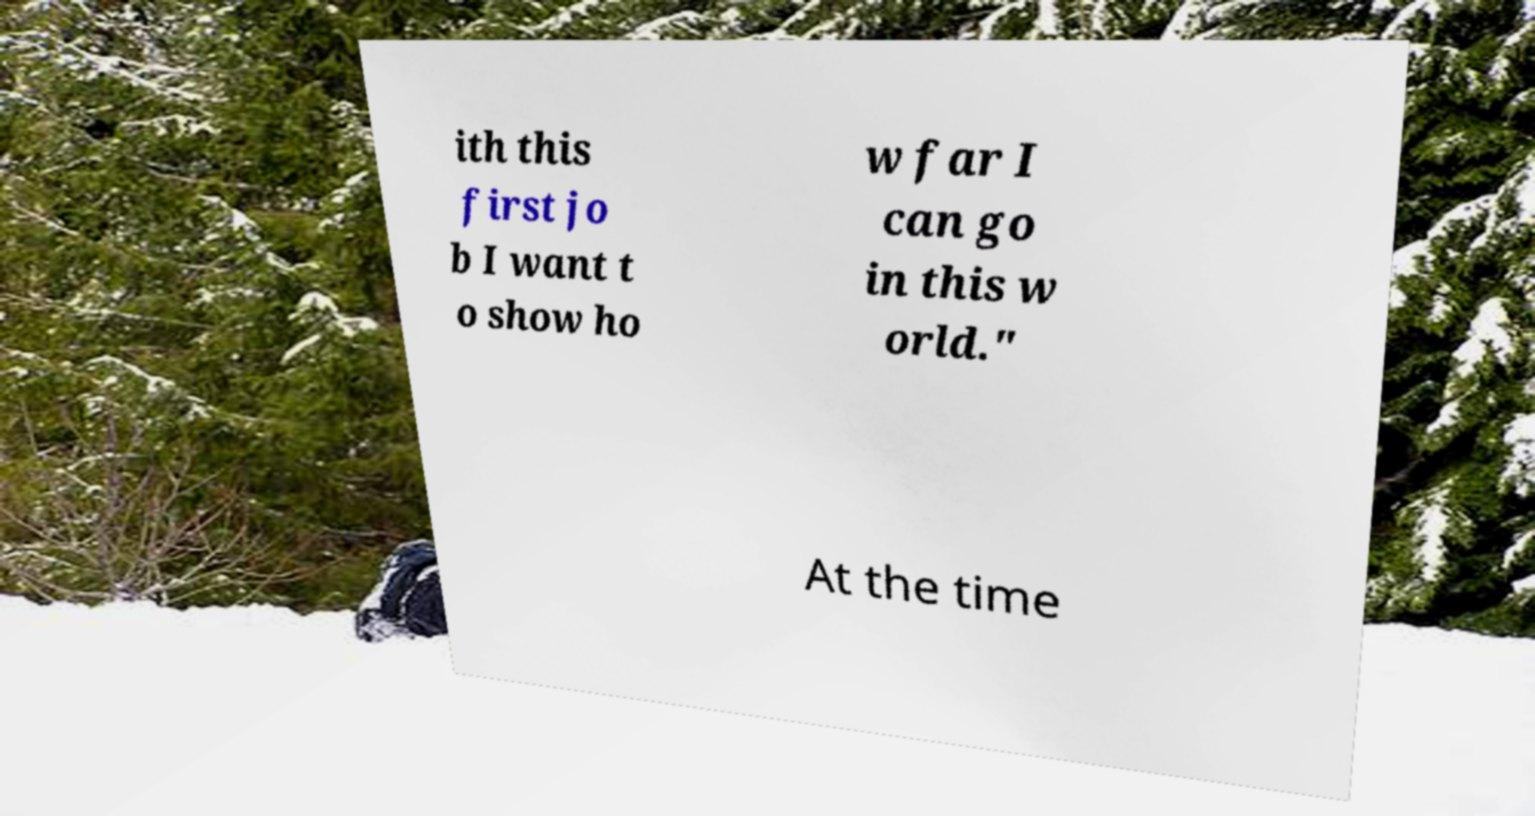Could you assist in decoding the text presented in this image and type it out clearly? ith this first jo b I want t o show ho w far I can go in this w orld." At the time 